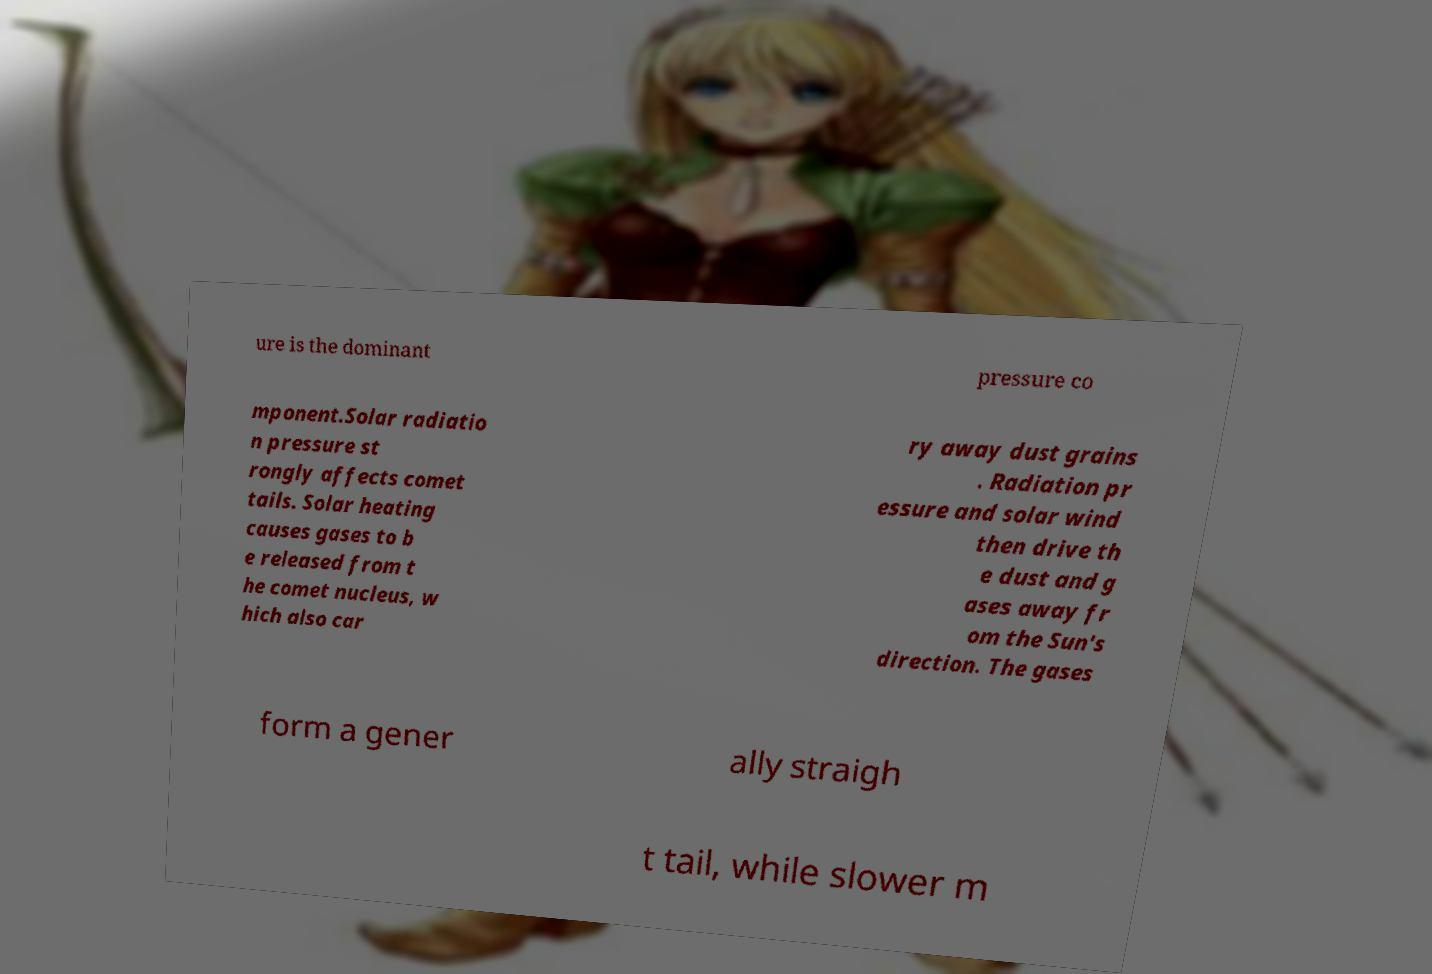What messages or text are displayed in this image? I need them in a readable, typed format. ure is the dominant pressure co mponent.Solar radiatio n pressure st rongly affects comet tails. Solar heating causes gases to b e released from t he comet nucleus, w hich also car ry away dust grains . Radiation pr essure and solar wind then drive th e dust and g ases away fr om the Sun's direction. The gases form a gener ally straigh t tail, while slower m 